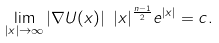<formula> <loc_0><loc_0><loc_500><loc_500>\lim _ { | x | \to \infty } | \nabla U ( x ) | \ | x | ^ { \frac { n - 1 } { 2 } } e ^ { | x | } = c .</formula> 